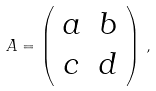Convert formula to latex. <formula><loc_0><loc_0><loc_500><loc_500>A = \left ( \begin{array} { c c } a & b \\ c & d \end{array} \right ) \, ,</formula> 